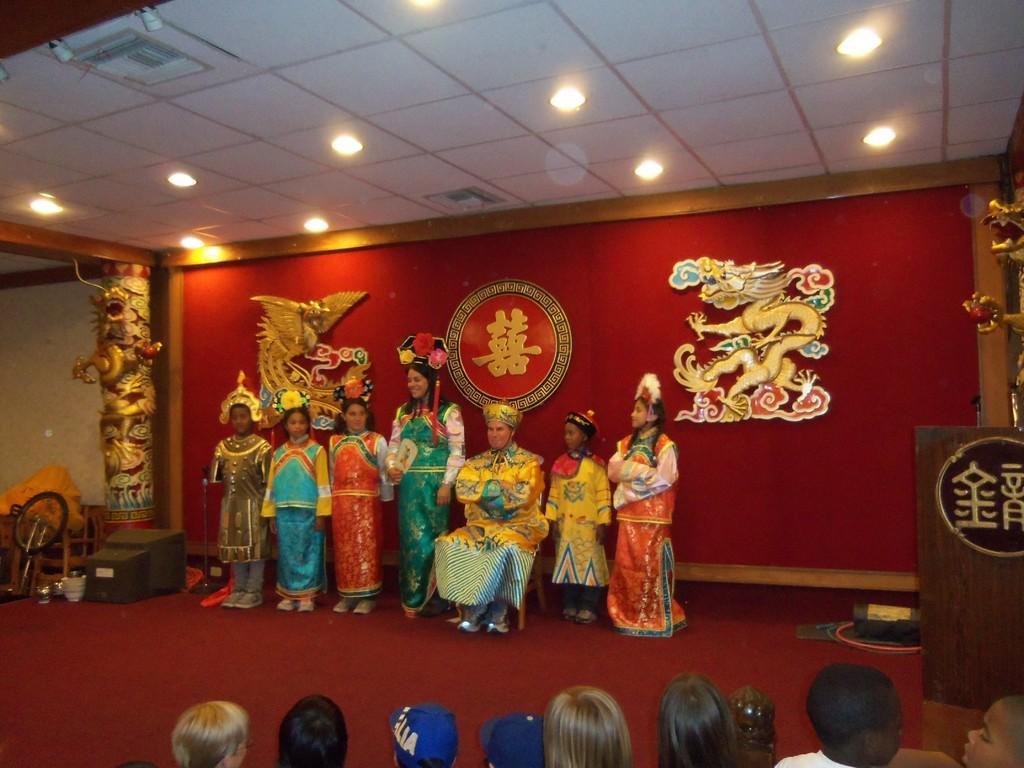How would you summarize this image in a sentence or two? In this image there are people standing, in front of them there is a stage, on that stage few people are standing and a man sitting on a chair, in the background there are pillars and a wall, on that wall there are pictures at the top there is a ceiling and lights. 